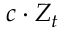<formula> <loc_0><loc_0><loc_500><loc_500>c \cdot Z _ { t }</formula> 